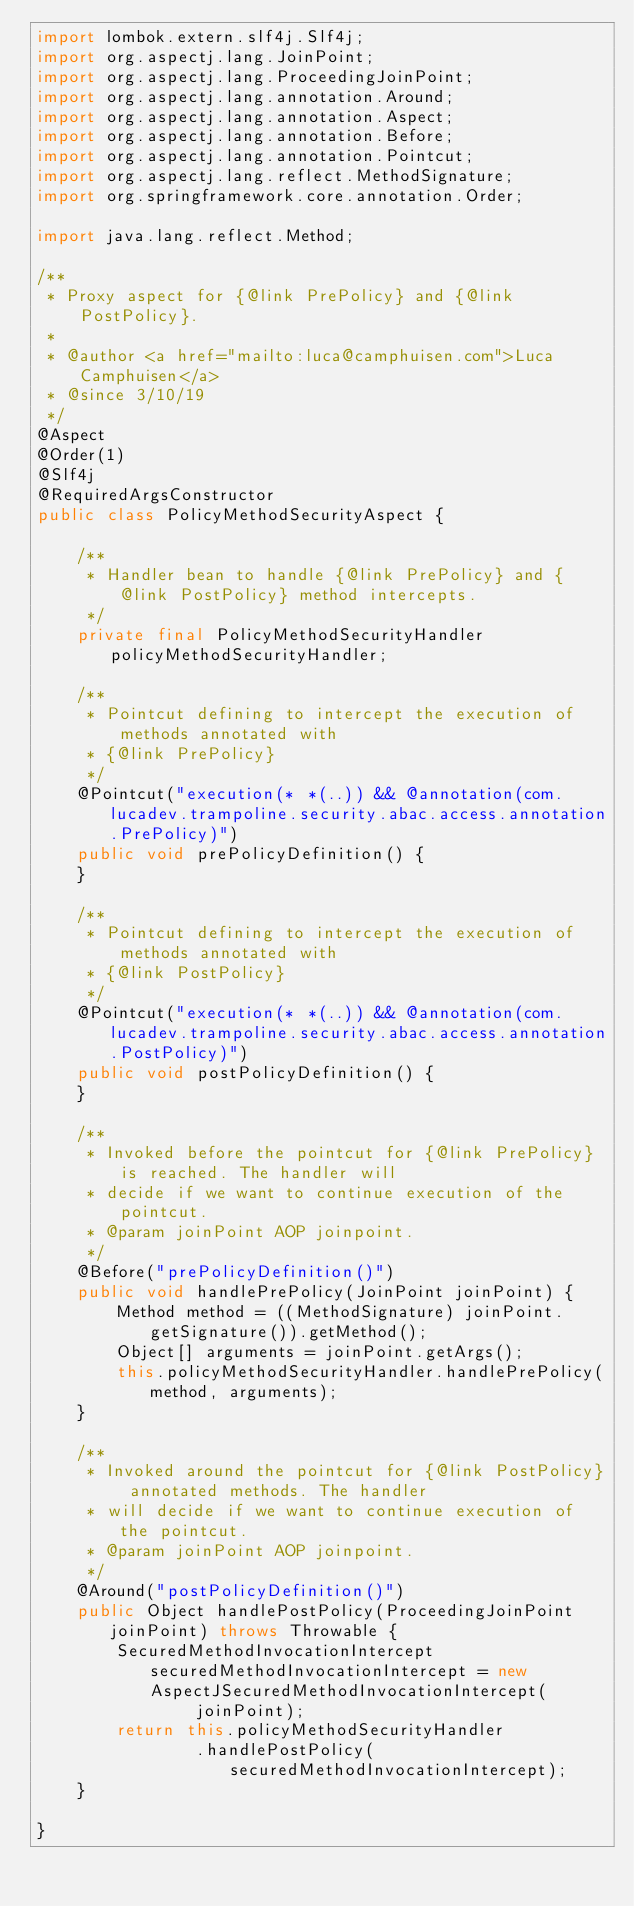Convert code to text. <code><loc_0><loc_0><loc_500><loc_500><_Java_>import lombok.extern.slf4j.Slf4j;
import org.aspectj.lang.JoinPoint;
import org.aspectj.lang.ProceedingJoinPoint;
import org.aspectj.lang.annotation.Around;
import org.aspectj.lang.annotation.Aspect;
import org.aspectj.lang.annotation.Before;
import org.aspectj.lang.annotation.Pointcut;
import org.aspectj.lang.reflect.MethodSignature;
import org.springframework.core.annotation.Order;

import java.lang.reflect.Method;

/**
 * Proxy aspect for {@link PrePolicy} and {@link PostPolicy}.
 *
 * @author <a href="mailto:luca@camphuisen.com">Luca Camphuisen</a>
 * @since 3/10/19
 */
@Aspect
@Order(1)
@Slf4j
@RequiredArgsConstructor
public class PolicyMethodSecurityAspect {

	/**
	 * Handler bean to handle {@link PrePolicy} and {@link PostPolicy} method intercepts.
	 */
	private final PolicyMethodSecurityHandler policyMethodSecurityHandler;

	/**
	 * Pointcut defining to intercept the execution of methods annotated with
	 * {@link PrePolicy}
	 */
	@Pointcut("execution(* *(..)) && @annotation(com.lucadev.trampoline.security.abac.access.annotation.PrePolicy)")
	public void prePolicyDefinition() {
	}

	/**
	 * Pointcut defining to intercept the execution of methods annotated with
	 * {@link PostPolicy}
	 */
	@Pointcut("execution(* *(..)) && @annotation(com.lucadev.trampoline.security.abac.access.annotation.PostPolicy)")
	public void postPolicyDefinition() {
	}

	/**
	 * Invoked before the pointcut for {@link PrePolicy} is reached. The handler will
	 * decide if we want to continue execution of the pointcut.
	 * @param joinPoint AOP joinpoint.
	 */
	@Before("prePolicyDefinition()")
	public void handlePrePolicy(JoinPoint joinPoint) {
		Method method = ((MethodSignature) joinPoint.getSignature()).getMethod();
		Object[] arguments = joinPoint.getArgs();
		this.policyMethodSecurityHandler.handlePrePolicy(method, arguments);
	}

	/**
	 * Invoked around the pointcut for {@link PostPolicy} annotated methods. The handler
	 * will decide if we want to continue execution of the pointcut.
	 * @param joinPoint AOP joinpoint.
	 */
	@Around("postPolicyDefinition()")
	public Object handlePostPolicy(ProceedingJoinPoint joinPoint) throws Throwable {
		SecuredMethodInvocationIntercept securedMethodInvocationIntercept = new AspectJSecuredMethodInvocationIntercept(
				joinPoint);
		return this.policyMethodSecurityHandler
				.handlePostPolicy(securedMethodInvocationIntercept);
	}

}
</code> 